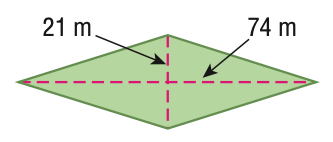Answer the mathemtical geometry problem and directly provide the correct option letter.
Question: Find the area of the figure. Round to the nearest tenth if necessary.
Choices: A: 190 B: 1554 C: 3108 D: 6216 C 